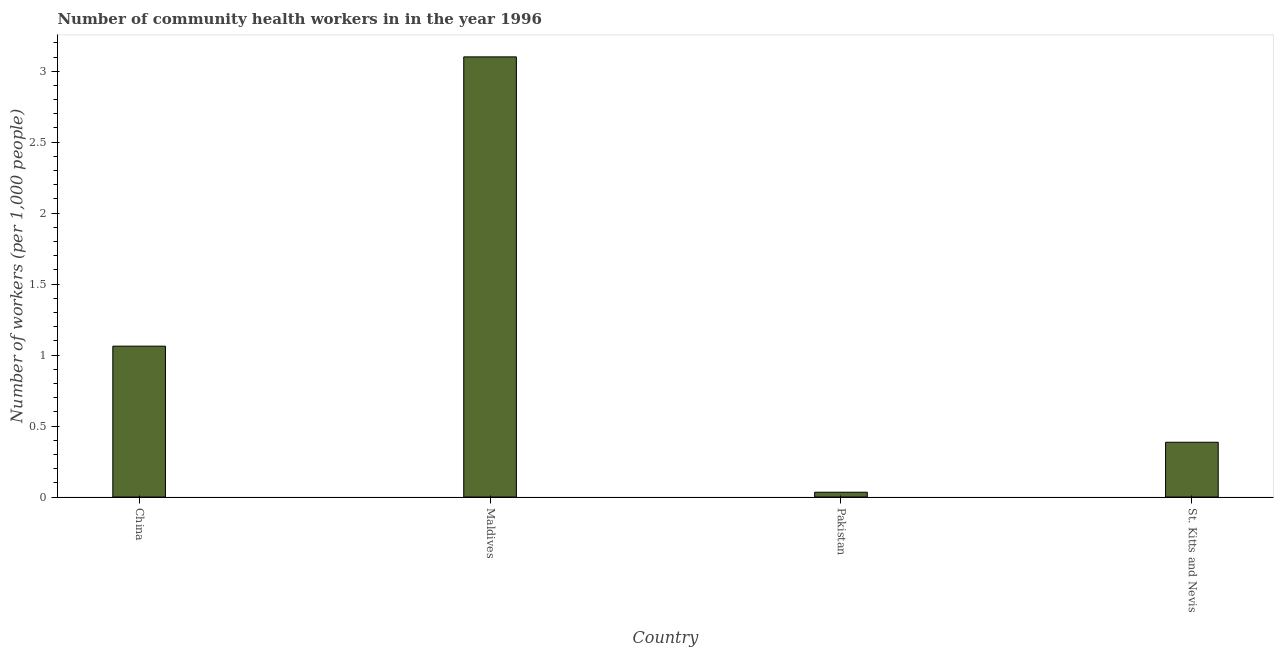What is the title of the graph?
Ensure brevity in your answer.  Number of community health workers in in the year 1996. What is the label or title of the Y-axis?
Offer a terse response. Number of workers (per 1,0 people). What is the number of community health workers in Pakistan?
Make the answer very short. 0.03. Across all countries, what is the maximum number of community health workers?
Give a very brief answer. 3.1. Across all countries, what is the minimum number of community health workers?
Your answer should be very brief. 0.03. In which country was the number of community health workers maximum?
Your answer should be very brief. Maldives. In which country was the number of community health workers minimum?
Give a very brief answer. Pakistan. What is the sum of the number of community health workers?
Make the answer very short. 4.58. What is the difference between the number of community health workers in China and Maldives?
Your answer should be very brief. -2.04. What is the average number of community health workers per country?
Offer a very short reply. 1.15. What is the median number of community health workers?
Make the answer very short. 0.72. In how many countries, is the number of community health workers greater than 1.5 ?
Offer a very short reply. 1. What is the ratio of the number of community health workers in China to that in Pakistan?
Your answer should be very brief. 31.27. Is the difference between the number of community health workers in China and Maldives greater than the difference between any two countries?
Provide a short and direct response. No. What is the difference between the highest and the second highest number of community health workers?
Your response must be concise. 2.04. Is the sum of the number of community health workers in China and Maldives greater than the maximum number of community health workers across all countries?
Offer a terse response. Yes. What is the difference between the highest and the lowest number of community health workers?
Offer a very short reply. 3.07. In how many countries, is the number of community health workers greater than the average number of community health workers taken over all countries?
Your answer should be compact. 1. How many bars are there?
Provide a short and direct response. 4. Are all the bars in the graph horizontal?
Your answer should be compact. No. What is the difference between two consecutive major ticks on the Y-axis?
Your answer should be compact. 0.5. What is the Number of workers (per 1,000 people) of China?
Ensure brevity in your answer.  1.06. What is the Number of workers (per 1,000 people) in Maldives?
Give a very brief answer. 3.1. What is the Number of workers (per 1,000 people) of Pakistan?
Make the answer very short. 0.03. What is the Number of workers (per 1,000 people) in St. Kitts and Nevis?
Give a very brief answer. 0.39. What is the difference between the Number of workers (per 1,000 people) in China and Maldives?
Provide a short and direct response. -2.04. What is the difference between the Number of workers (per 1,000 people) in China and Pakistan?
Provide a short and direct response. 1.03. What is the difference between the Number of workers (per 1,000 people) in China and St. Kitts and Nevis?
Offer a terse response. 0.68. What is the difference between the Number of workers (per 1,000 people) in Maldives and Pakistan?
Make the answer very short. 3.07. What is the difference between the Number of workers (per 1,000 people) in Maldives and St. Kitts and Nevis?
Your answer should be compact. 2.71. What is the difference between the Number of workers (per 1,000 people) in Pakistan and St. Kitts and Nevis?
Offer a very short reply. -0.35. What is the ratio of the Number of workers (per 1,000 people) in China to that in Maldives?
Your answer should be very brief. 0.34. What is the ratio of the Number of workers (per 1,000 people) in China to that in Pakistan?
Keep it short and to the point. 31.27. What is the ratio of the Number of workers (per 1,000 people) in China to that in St. Kitts and Nevis?
Your response must be concise. 2.75. What is the ratio of the Number of workers (per 1,000 people) in Maldives to that in Pakistan?
Offer a terse response. 91.21. What is the ratio of the Number of workers (per 1,000 people) in Maldives to that in St. Kitts and Nevis?
Provide a succinct answer. 8.03. What is the ratio of the Number of workers (per 1,000 people) in Pakistan to that in St. Kitts and Nevis?
Your answer should be compact. 0.09. 